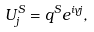Convert formula to latex. <formula><loc_0><loc_0><loc_500><loc_500>U ^ { S } _ { j } = q ^ { S } e ^ { i \gamma j } ,</formula> 